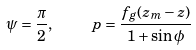<formula> <loc_0><loc_0><loc_500><loc_500>\psi = \frac { \pi } { 2 } , \quad \ p = \frac { f _ { g } ( z _ { m } - z ) } { 1 + \sin \phi }</formula> 